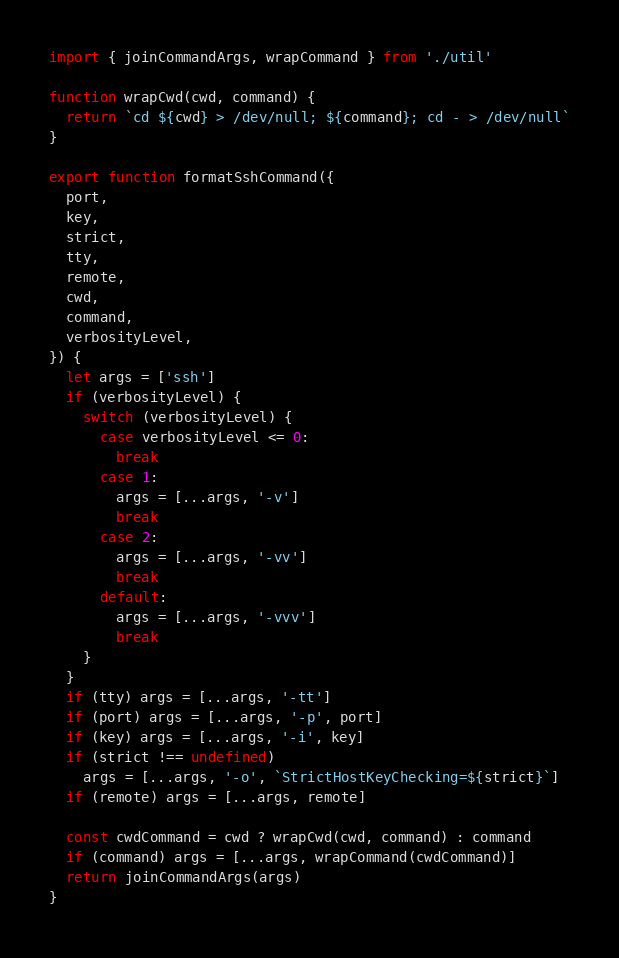Convert code to text. <code><loc_0><loc_0><loc_500><loc_500><_JavaScript_>import { joinCommandArgs, wrapCommand } from './util'

function wrapCwd(cwd, command) {
  return `cd ${cwd} > /dev/null; ${command}; cd - > /dev/null`
}

export function formatSshCommand({
  port,
  key,
  strict,
  tty,
  remote,
  cwd,
  command,
  verbosityLevel,
}) {
  let args = ['ssh']
  if (verbosityLevel) {
    switch (verbosityLevel) {
      case verbosityLevel <= 0:
        break
      case 1:
        args = [...args, '-v']
        break
      case 2:
        args = [...args, '-vv']
        break
      default:
        args = [...args, '-vvv']
        break
    }
  }
  if (tty) args = [...args, '-tt']
  if (port) args = [...args, '-p', port]
  if (key) args = [...args, '-i', key]
  if (strict !== undefined)
    args = [...args, '-o', `StrictHostKeyChecking=${strict}`]
  if (remote) args = [...args, remote]

  const cwdCommand = cwd ? wrapCwd(cwd, command) : command
  if (command) args = [...args, wrapCommand(cwdCommand)]
  return joinCommandArgs(args)
}
</code> 